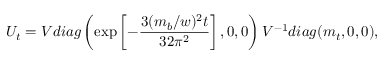<formula> <loc_0><loc_0><loc_500><loc_500>U _ { t } = V d i a g \left ( \exp \left [ - \frac { 3 ( m _ { b } / w ) ^ { 2 } t } { 3 2 \pi ^ { 2 } } \right ] , 0 , 0 \right ) V ^ { - 1 } d i a g ( m _ { t } , 0 , 0 ) ,</formula> 